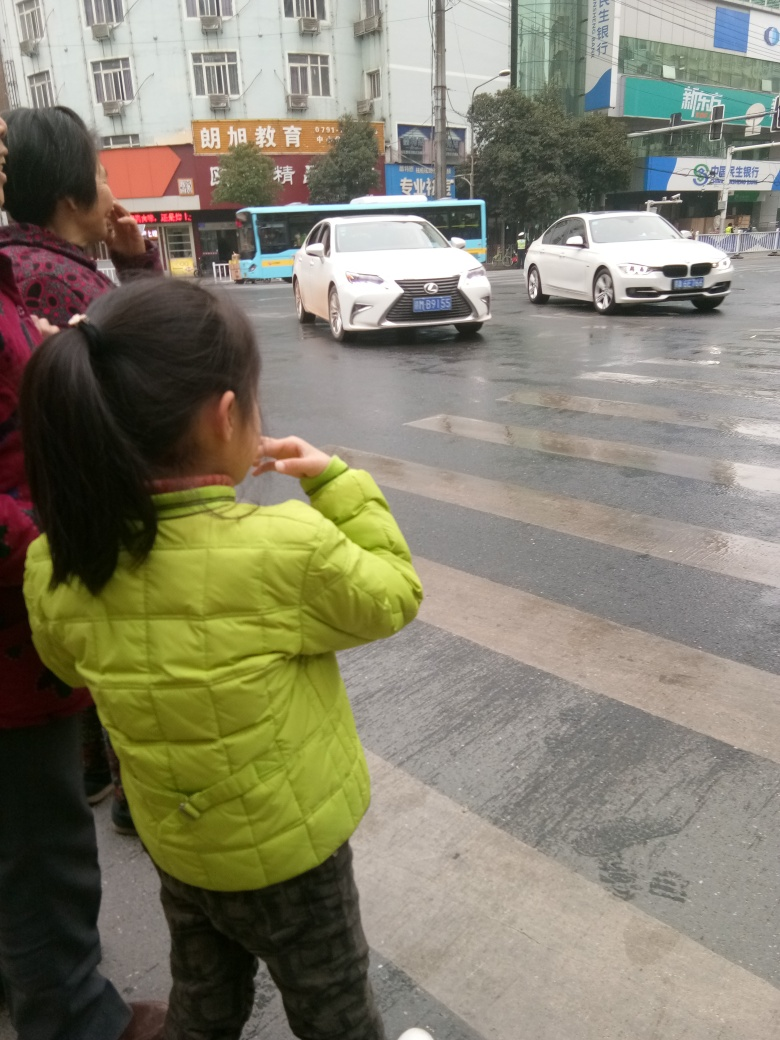How is the sharpness of the image? The sharpness of the image is somewhat lacking, with a slight blur observable in the moving vehicles and the individuals, likely due to movement and the camera's focus settings. The overall composition, lighting, and depth of field suggest a candid, quick snapshot, rather than a premeditated photograph, contributing to the moderate sharpness. 